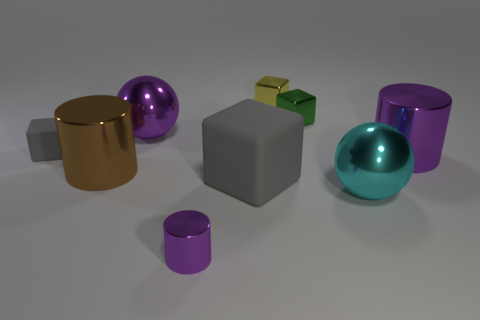What number of objects are behind the small gray matte block and to the left of the small metallic cylinder?
Make the answer very short. 1. What is the shape of the big purple shiny object that is on the left side of the big cyan thing?
Provide a succinct answer. Sphere. Is the number of matte things that are behind the big brown metal cylinder less than the number of tiny green cubes in front of the big matte cube?
Keep it short and to the point. No. Does the ball that is on the right side of the yellow block have the same material as the large ball that is to the left of the cyan thing?
Give a very brief answer. Yes. What is the shape of the big cyan shiny thing?
Provide a short and direct response. Sphere. Are there more cyan shiny objects behind the green thing than cylinders in front of the large brown cylinder?
Your response must be concise. No. There is a large purple shiny object that is on the right side of the green metallic block; does it have the same shape as the small yellow thing that is behind the big cyan sphere?
Provide a succinct answer. No. What number of other objects are the same size as the purple metallic ball?
Offer a terse response. 4. What is the size of the purple shiny sphere?
Offer a very short reply. Large. Are the big purple cylinder behind the large cyan metallic object and the cyan object made of the same material?
Keep it short and to the point. Yes. 